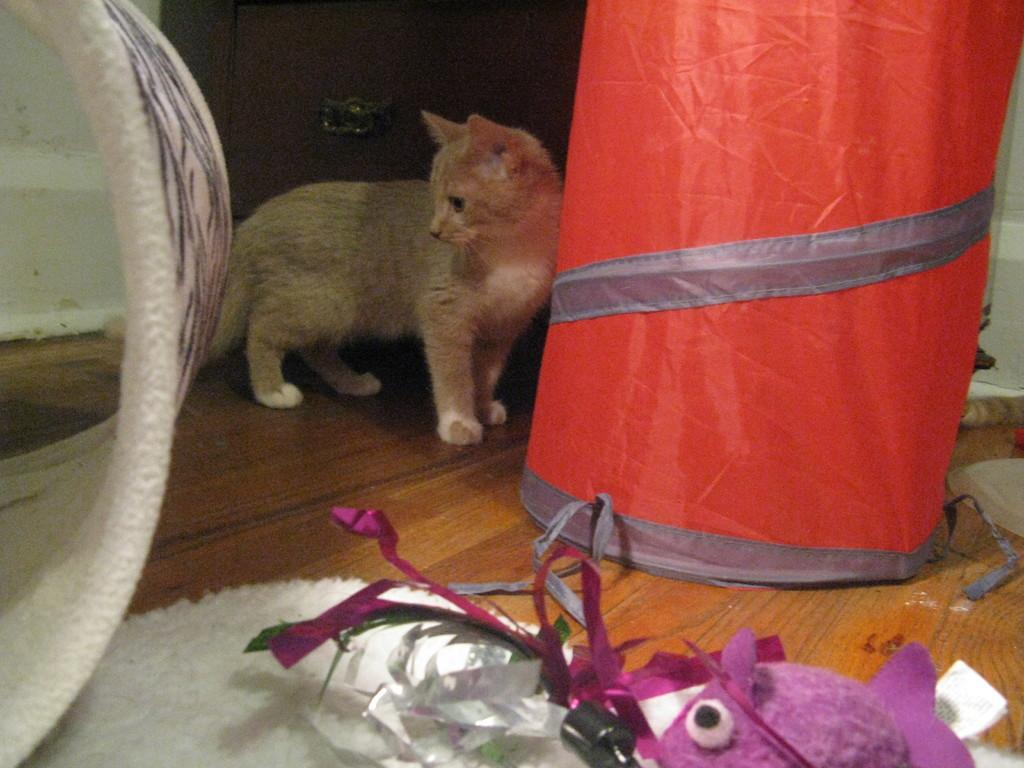What animal is standing in the image? There is a cat standing in the image. What is on the floor in the image? There is a floor mat, toys, bags, and other objects on the floor. Can you describe the door visible in the background of the image? There is a door visible in the background of the image, but its specific features are not mentioned in the facts. How many types of items are on the floor in the image? There are four types of items on the floor: a floor mat, toys, bags, and other objects. What type of cough can be heard coming from the cat in the image? There is no indication of any sound, including a cough, in the image. The cat is not making any noise, and there is no mention of a cough in the provided facts. 